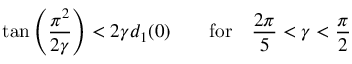<formula> <loc_0><loc_0><loc_500><loc_500>\tan \left ( \frac { \pi ^ { 2 } } { 2 \gamma } \right ) < 2 \gamma d _ { 1 } ( 0 ) \quad f o r \quad \frac { 2 \pi } { 5 } < \gamma < \frac { \pi } { 2 }</formula> 